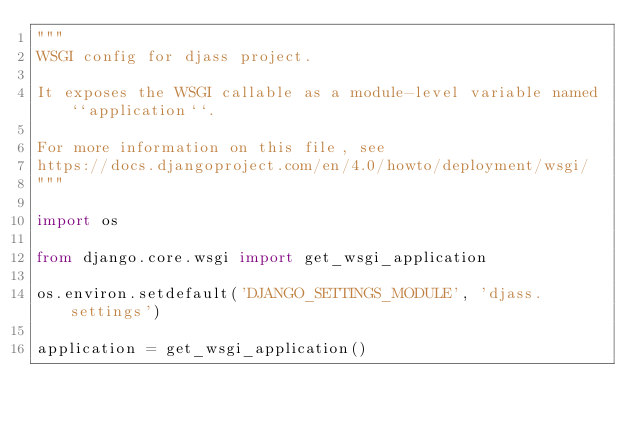<code> <loc_0><loc_0><loc_500><loc_500><_Python_>"""
WSGI config for djass project.

It exposes the WSGI callable as a module-level variable named ``application``.

For more information on this file, see
https://docs.djangoproject.com/en/4.0/howto/deployment/wsgi/
"""

import os

from django.core.wsgi import get_wsgi_application

os.environ.setdefault('DJANGO_SETTINGS_MODULE', 'djass.settings')

application = get_wsgi_application()
</code> 